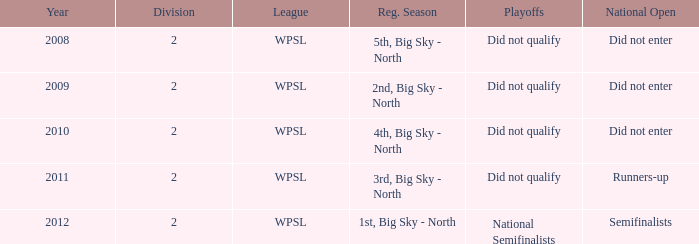What is the smallest division number? 2.0. 